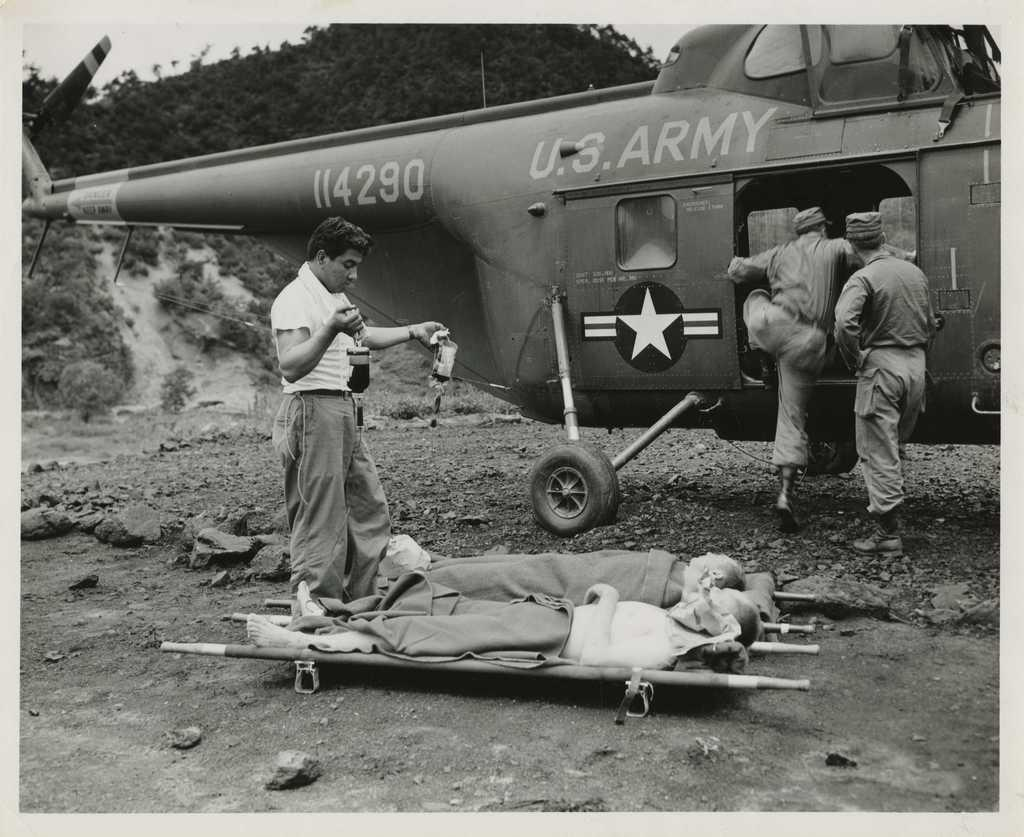<image>
Relay a brief, clear account of the picture shown. Two men lay on stretchers outside an Army helicopter while a medic holds bags of blood in his hands. 